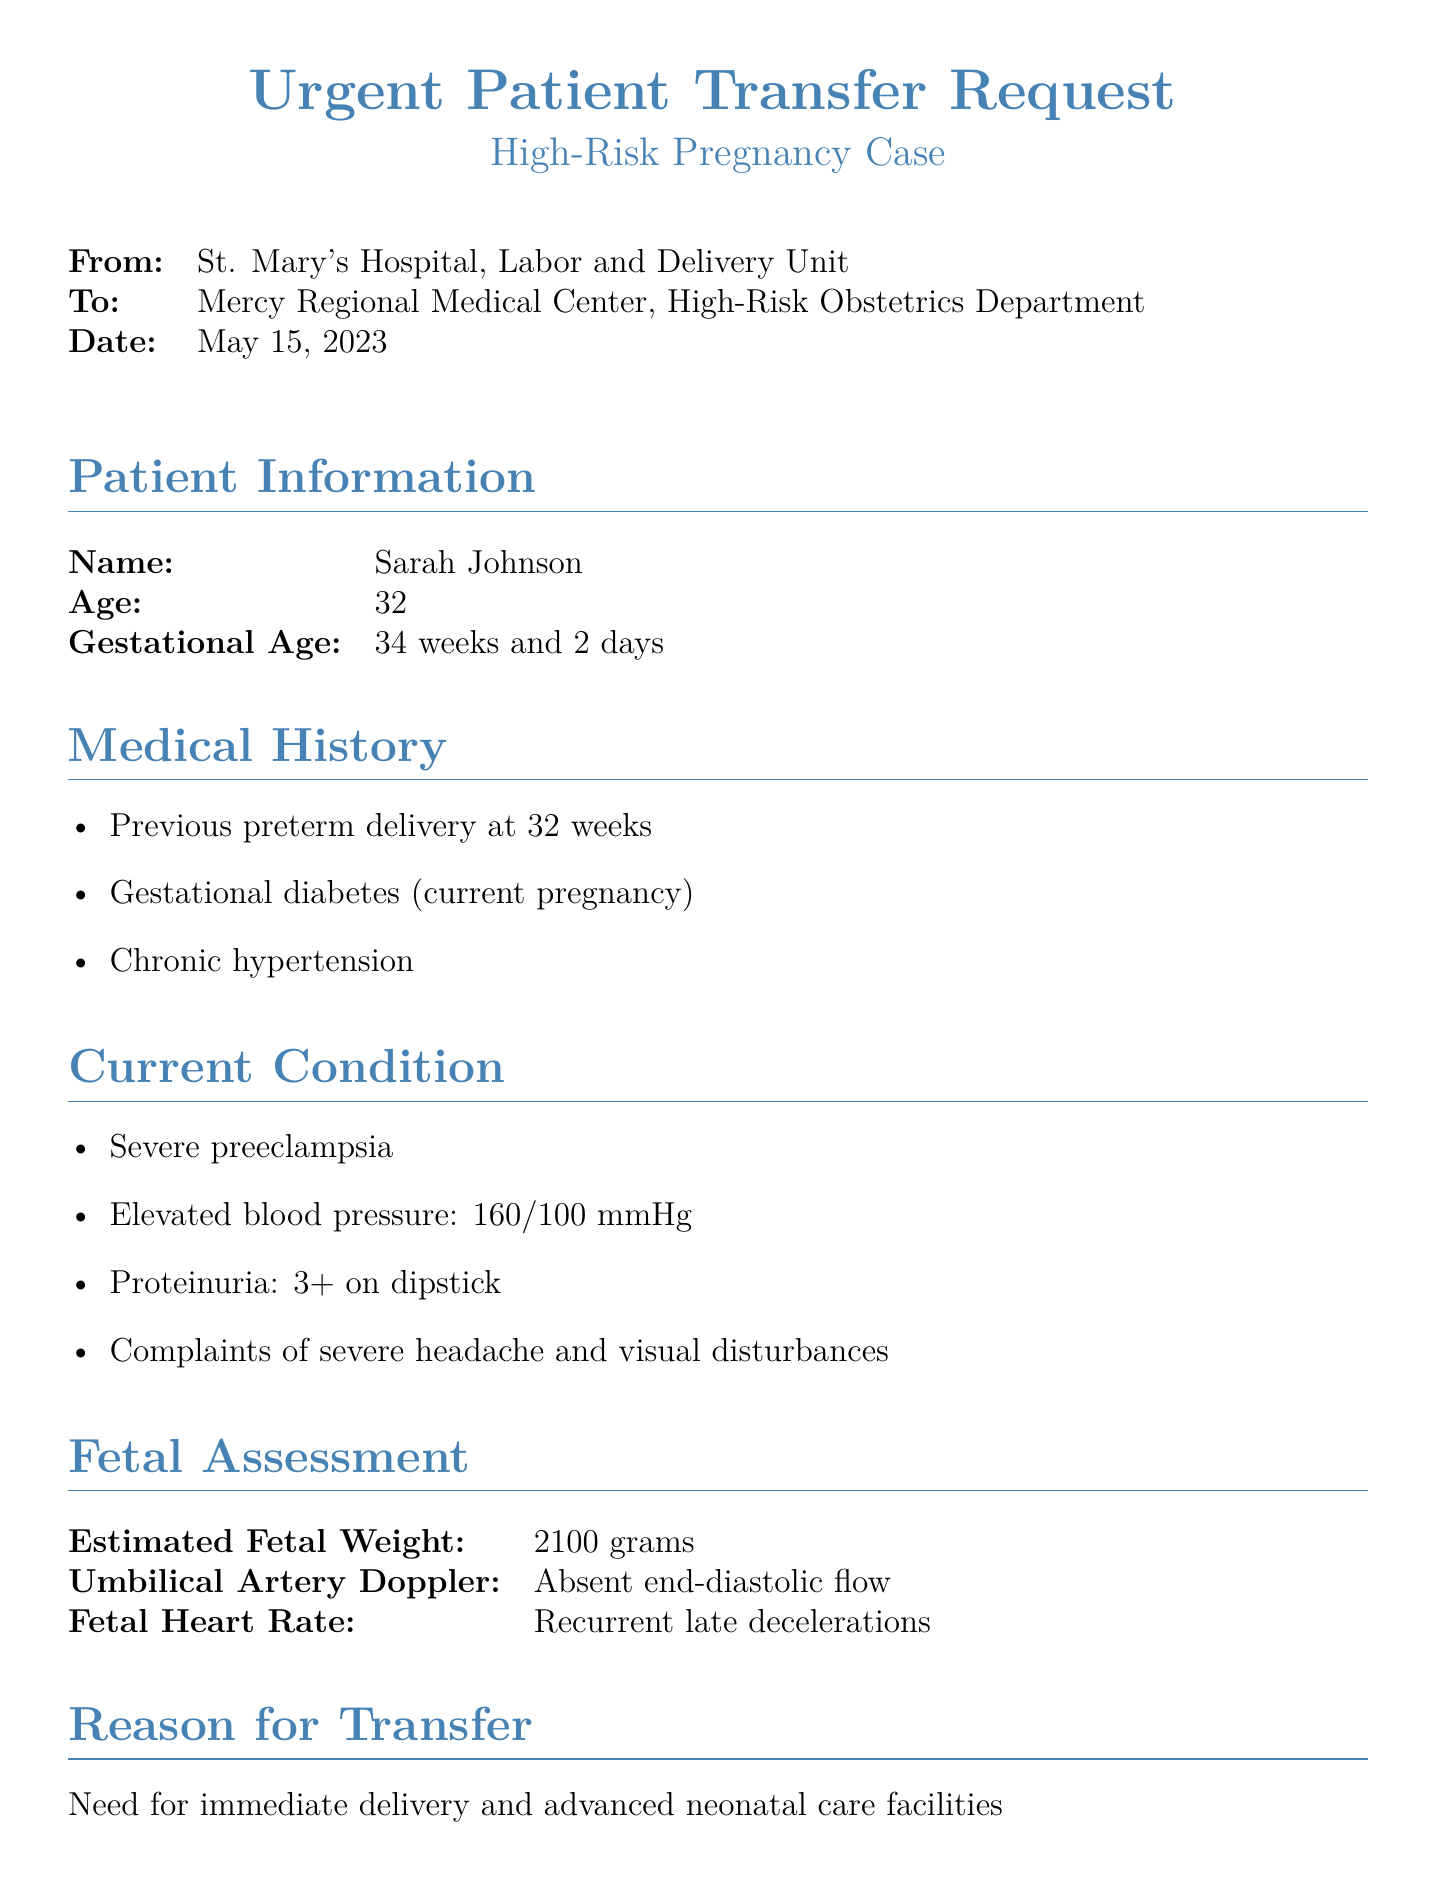What is the patient's name? The patient's name is listed at the beginning of the patient information section.
Answer: Sarah Johnson What is the gestational age of the patient? The gestational age is included in the patient information section.
Answer: 34 weeks and 2 days What is the estimated fetal weight? This information can be found in the fetal assessment section of the document.
Answer: 2100 grams What is the significance of absent end-diastolic flow? Absent end-diastolic flow indicates potential fetal compromise and is noted in the fetal assessment.
Answer: Indicates potential fetal compromise What medication was given for fetal lung maturity? The current management section of the document specifies the medication used for fetal lung maturity.
Answer: Betamethasone What is the estimated arrival time for the transfer? The estimated arrival time is detailed under the transfer arrangements section.
Answer: Within 45 minutes What is the patient's blood pressure reading? The blood pressure reading is provided in the current condition section.
Answer: 160/100 mmHg Who is the referring obstetrician? The name of the referring obstetrician is found in the contact information section.
Answer: Dr. Emily Chen What is the primary reason for transferring the patient? The reason for transfer is stated in the reason for transfer section.
Answer: Need for immediate delivery and advanced neonatal care facilities 